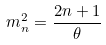Convert formula to latex. <formula><loc_0><loc_0><loc_500><loc_500>m _ { n } ^ { 2 } = \frac { 2 n + 1 } { \theta }</formula> 